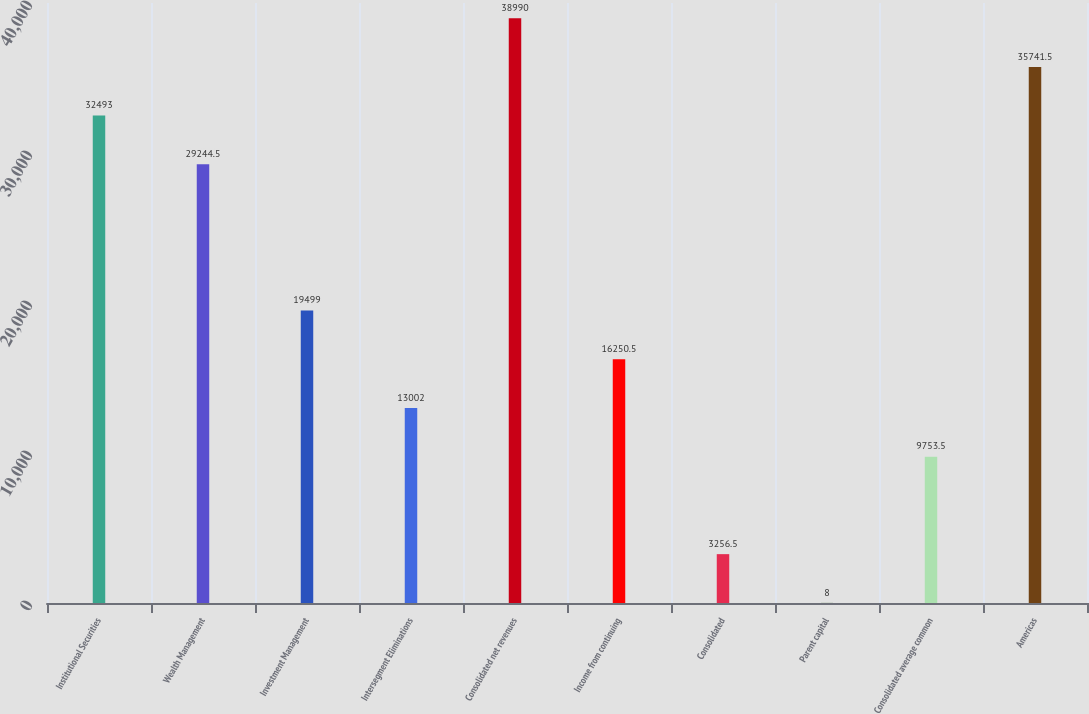<chart> <loc_0><loc_0><loc_500><loc_500><bar_chart><fcel>Institutional Securities<fcel>Wealth Management<fcel>Investment Management<fcel>Intersegment Eliminations<fcel>Consolidated net revenues<fcel>Income from continuing<fcel>Consolidated<fcel>Parent capital<fcel>Consolidated average common<fcel>Americas<nl><fcel>32493<fcel>29244.5<fcel>19499<fcel>13002<fcel>38990<fcel>16250.5<fcel>3256.5<fcel>8<fcel>9753.5<fcel>35741.5<nl></chart> 